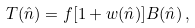<formula> <loc_0><loc_0><loc_500><loc_500>T ( \hat { n } ) = f [ 1 + w ( \hat { n } ) ] B ( \hat { n } ) \, ,</formula> 